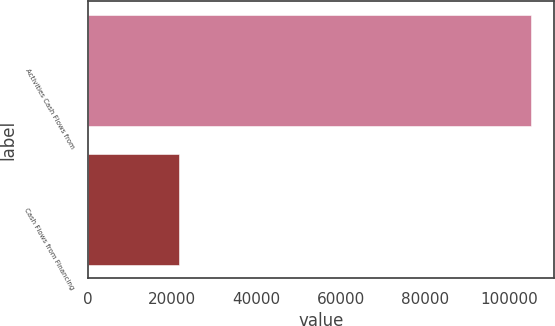<chart> <loc_0><loc_0><loc_500><loc_500><bar_chart><fcel>Activities Cash Flows from<fcel>Cash Flows from Financing<nl><fcel>105221<fcel>21489<nl></chart> 